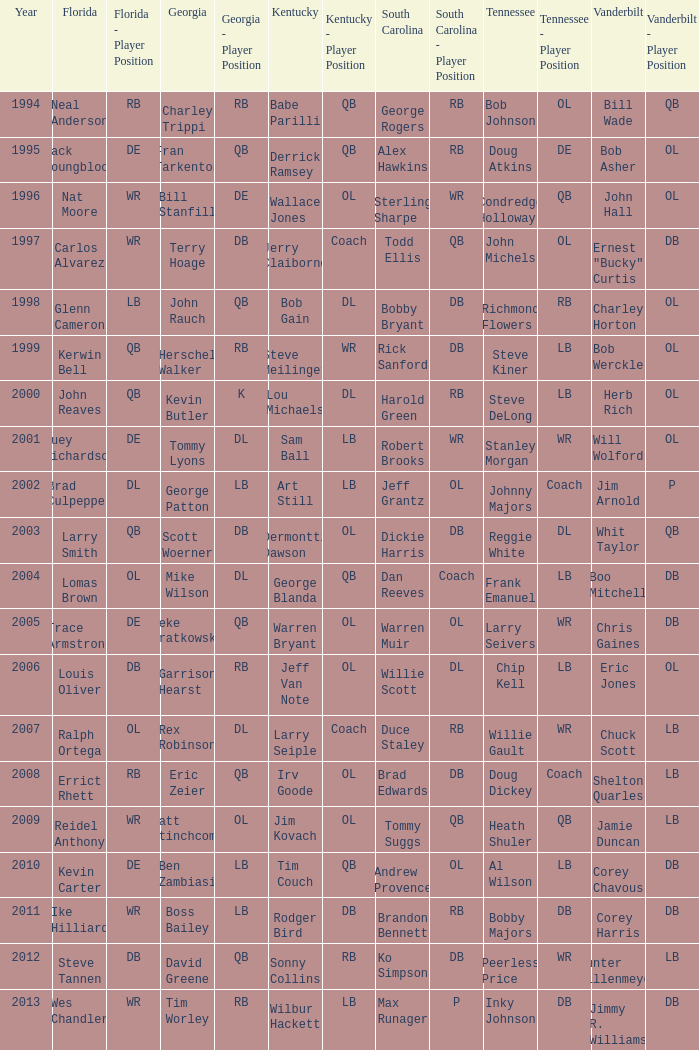What is the total Year of jeff van note ( Kentucky) 2006.0. 